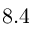Convert formula to latex. <formula><loc_0><loc_0><loc_500><loc_500>8 . 4</formula> 